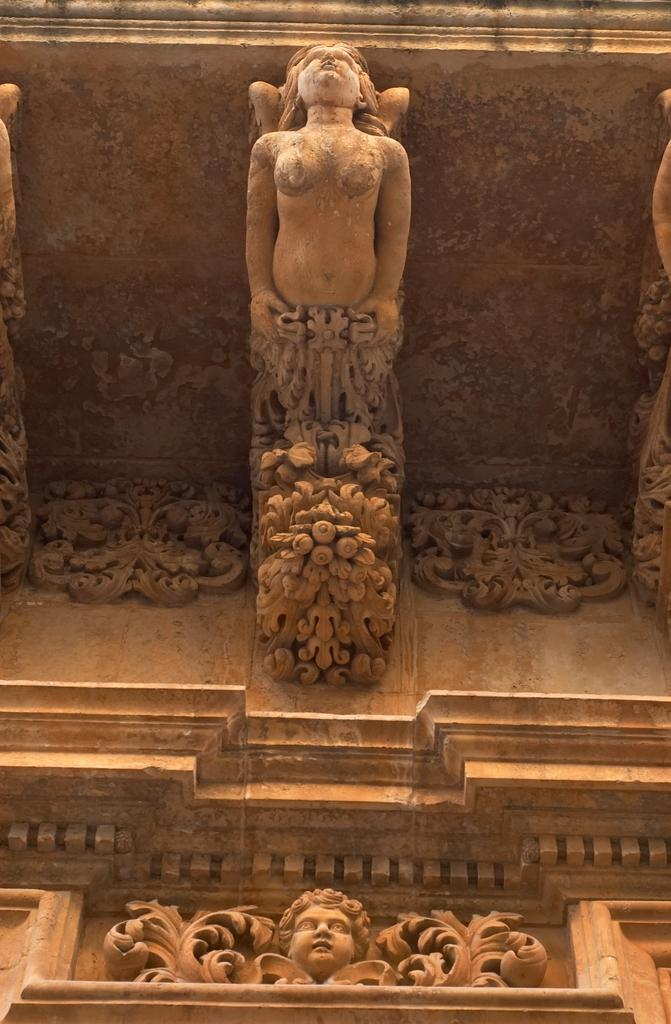What is the main structure visible in the image? There is a building in the image. Are there any decorative elements on the building? Yes, the building has statues on it. How many mice can be seen running around the building in the image? There are no mice visible in the image; it only shows the building and its statues. 